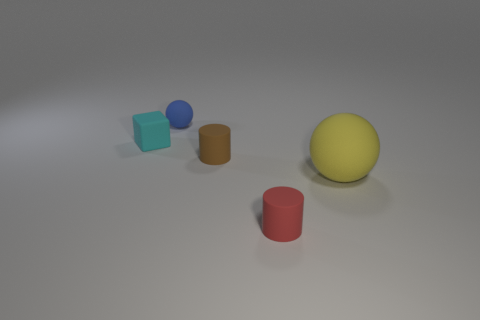There is a object that is in front of the sphere in front of the block; what is its material?
Your response must be concise. Rubber. Are there more rubber spheres behind the large matte ball than tiny gray rubber cylinders?
Your answer should be very brief. Yes. What number of other things are there of the same size as the cyan thing?
Provide a short and direct response. 3. What is the color of the cylinder in front of the matte ball to the right of the tiny rubber cylinder in front of the yellow thing?
Provide a short and direct response. Red. How many cyan matte things are to the right of the small ball behind the cylinder that is behind the large yellow ball?
Provide a succinct answer. 0. Is there anything else that has the same color as the large matte object?
Your response must be concise. No. There is a matte cylinder behind the yellow sphere; does it have the same size as the tiny blue rubber object?
Offer a very short reply. Yes. How many blue things are on the right side of the rubber thing that is behind the tiny block?
Give a very brief answer. 0. Is there a yellow rubber sphere behind the thing that is to the left of the sphere on the left side of the yellow rubber sphere?
Offer a very short reply. No. What material is the tiny thing that is the same shape as the big yellow matte object?
Your answer should be compact. Rubber. 